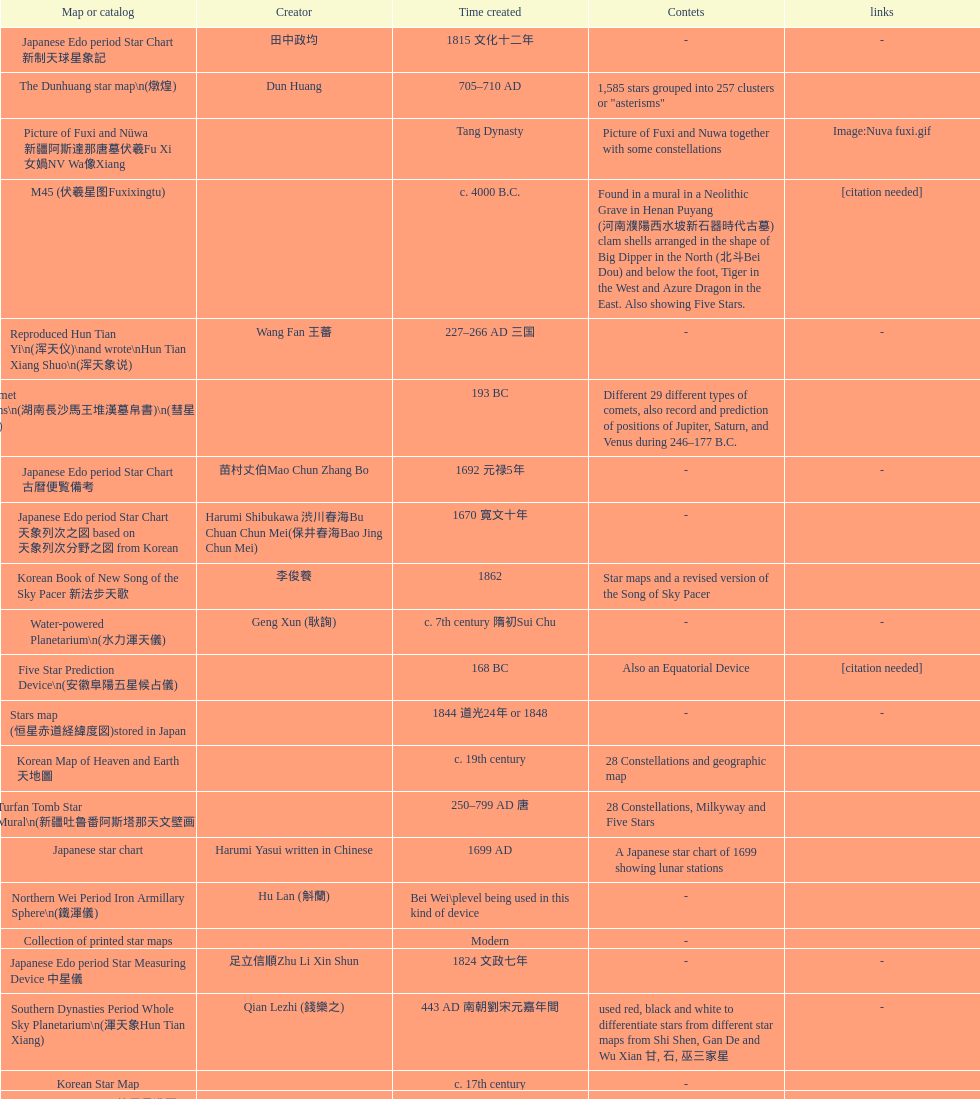What is the difference between the five star prediction device's date of creation and the han comet diagrams' date of creation? 25 years. 